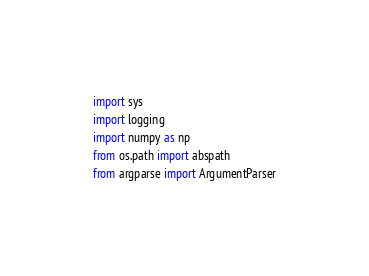Convert code to text. <code><loc_0><loc_0><loc_500><loc_500><_Python_>import sys
import logging
import numpy as np
from os.path import abspath
from argparse import ArgumentParser</code> 